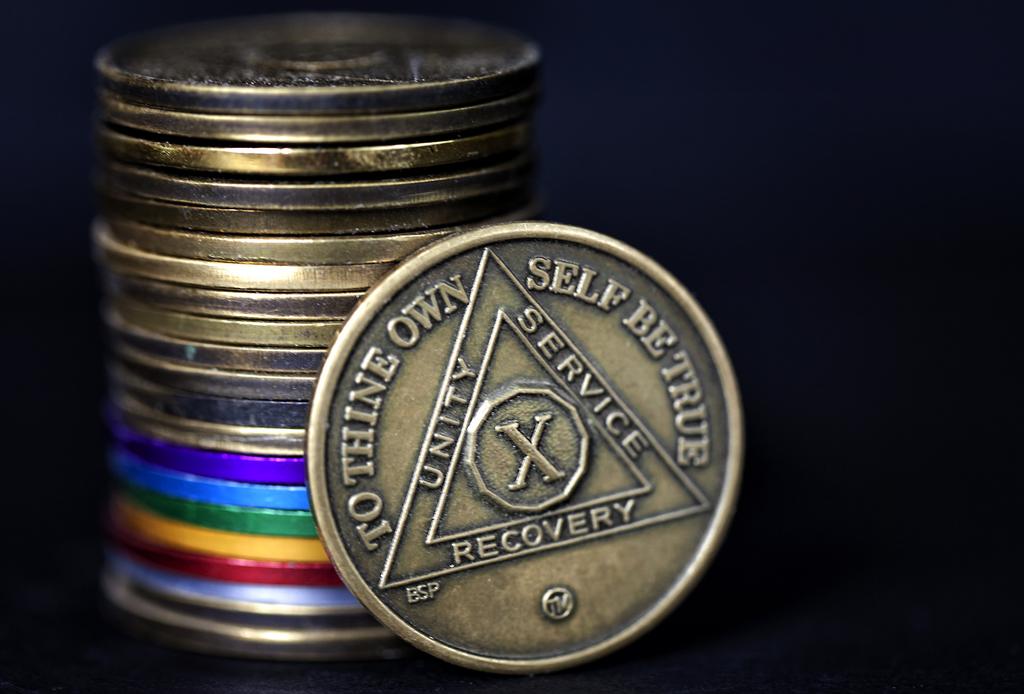What three words are within the triangle?
Provide a short and direct response. Unity service recovery. 